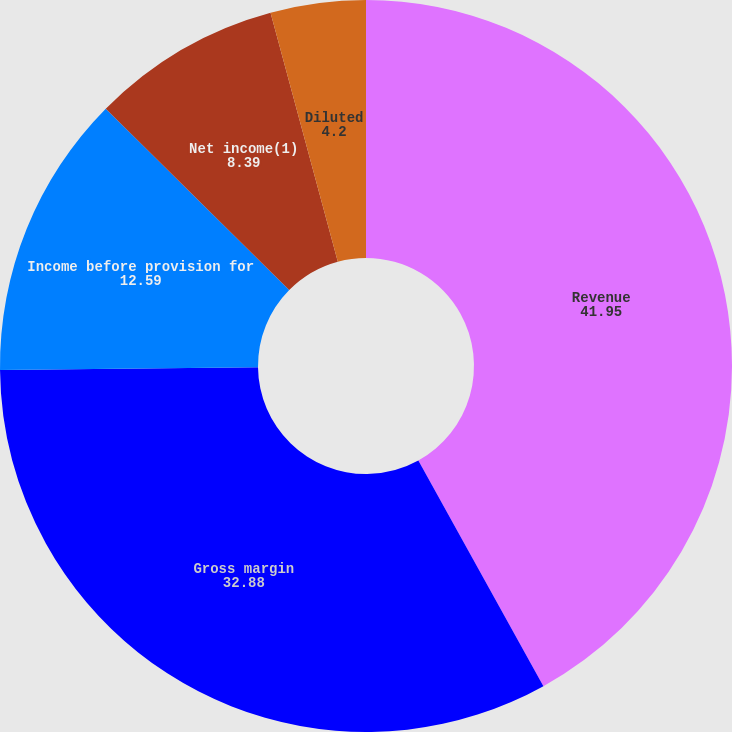Convert chart. <chart><loc_0><loc_0><loc_500><loc_500><pie_chart><fcel>Revenue<fcel>Gross margin<fcel>Income before provision for<fcel>Net income(1)<fcel>Basic<fcel>Diluted<nl><fcel>41.95%<fcel>32.88%<fcel>12.59%<fcel>8.39%<fcel>0.0%<fcel>4.2%<nl></chart> 